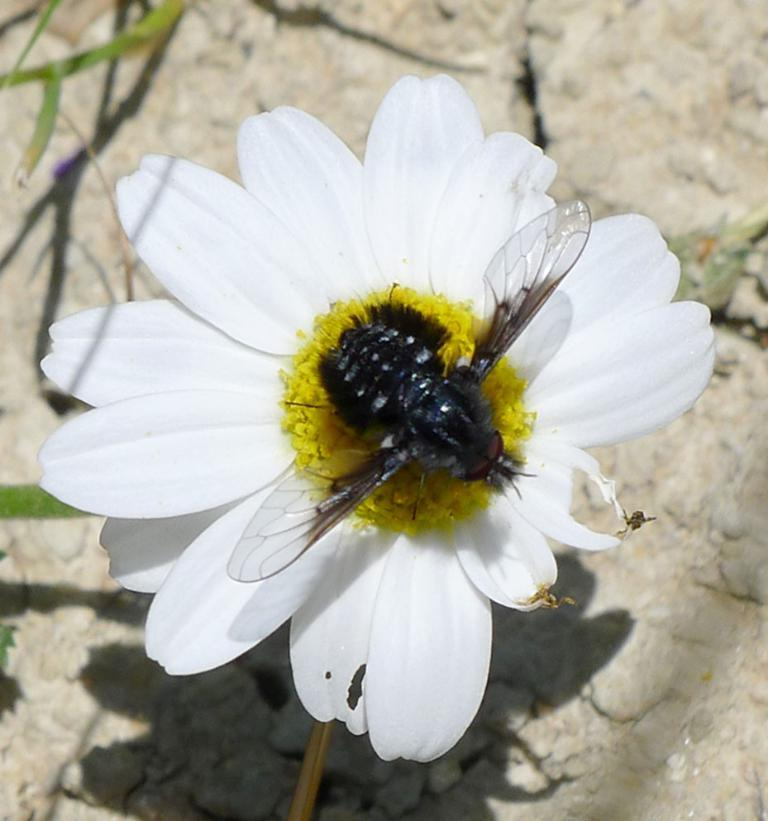What type of flower is in the image? There is a white flower in the image. Is there anything interacting with the flower? Yes, a honey bee is present on the flower. Can you describe the flower's structure? The flower has a stem. How many toes can be seen on the flower in the image? There are no toes visible in the image, as it features a flower and a honey bee. 